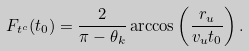<formula> <loc_0><loc_0><loc_500><loc_500>F _ { t ^ { c } } ( t _ { 0 } ) = \frac { 2 } { \pi - \theta _ { k } } \arccos \left ( \frac { r _ { u } } { v _ { u } t _ { 0 } } \right ) .</formula> 